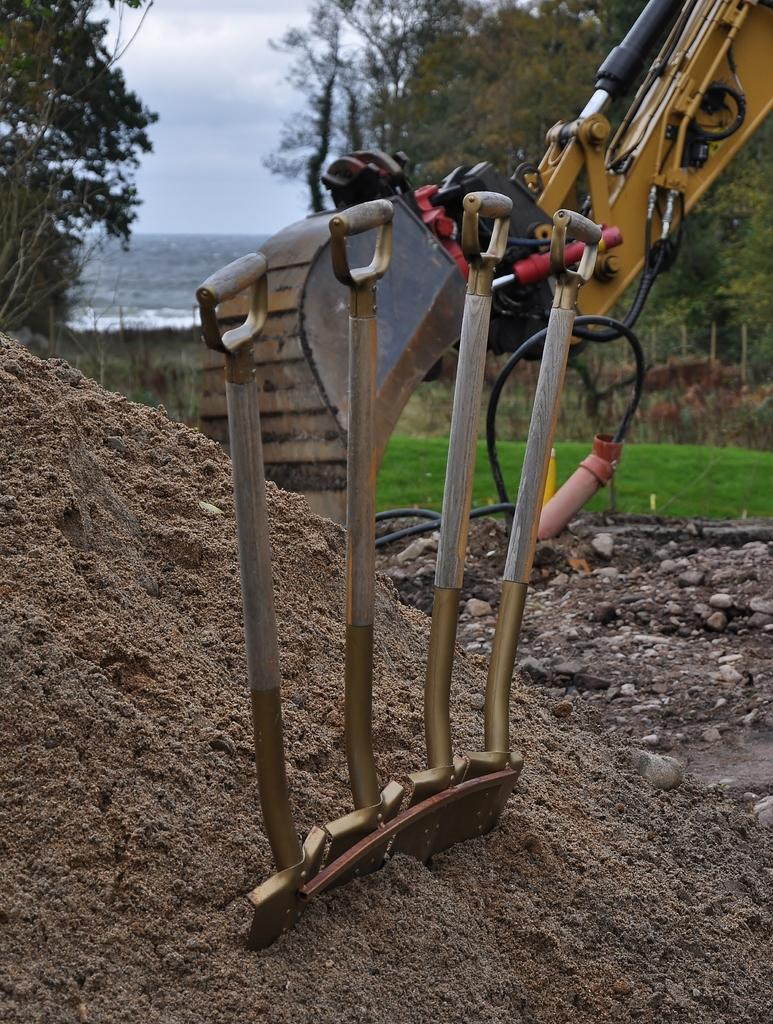What is placed on the sand in the image? There is an object placed on the sand in the image. What is the JCP in the image? The JCP in the image is not clearly defined, but it could be a reference to a Joint Commissioning Plan or a similar term. What type of vegetation is visible in the background of the image? There is grass, trees, and a river in the background of the image. What part of the natural environment is visible in the image? The sky is visible in the background of the image. What type of parcel is floating on the sea in the image? There is no sea or parcel present in the image; it features an object placed on the sand and a river in the background. What type of flooring is visible in the image? There is no flooring visible in the image, as it is set on sand and in a natural environment. 